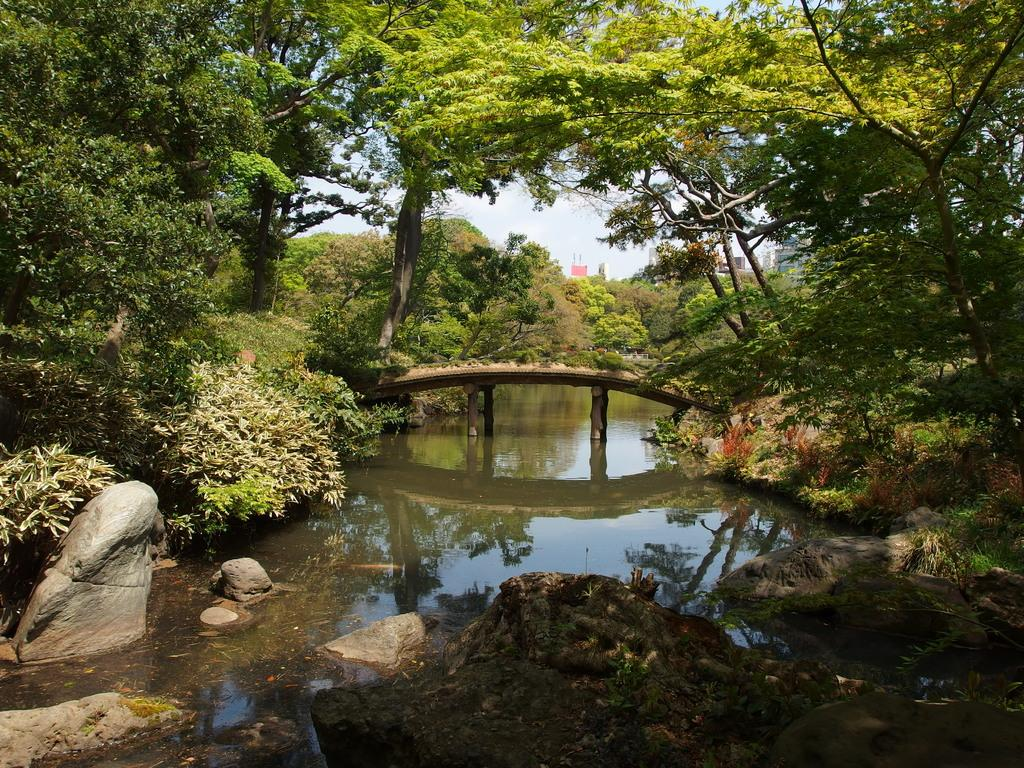What is the main feature of the image? The main feature of the image is a water surface. What can be seen around the water surface? There are plants and trees around the water surface. Is there any structure that crosses the water surface? Yes, there is a bridge across the water surface. What type of songs can be heard coming from the trees in the image? There are no songs or sounds mentioned in the image, as it only features a water surface, plants, trees, and a bridge. 